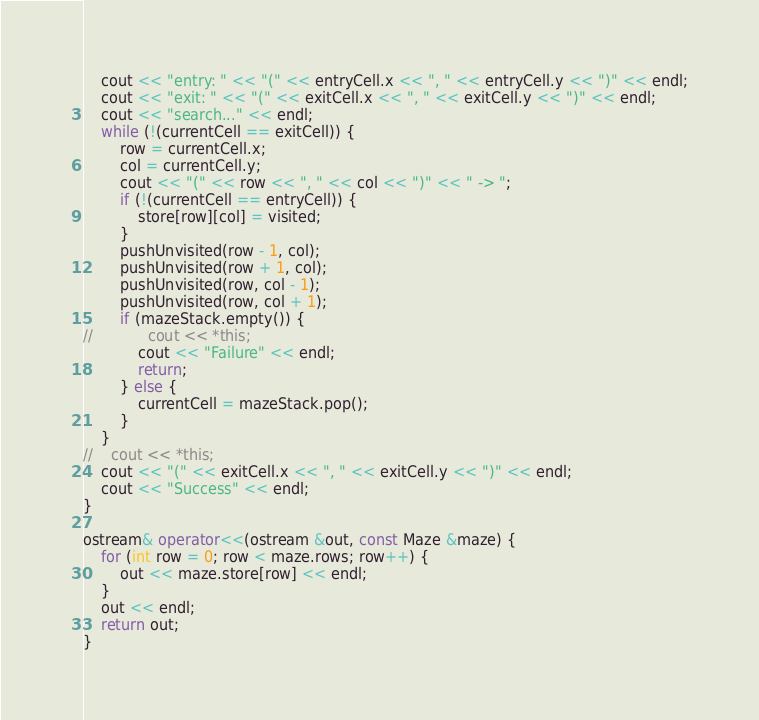Convert code to text. <code><loc_0><loc_0><loc_500><loc_500><_C++_>    cout << "entry: " << "(" << entryCell.x << ", " << entryCell.y << ")" << endl;
    cout << "exit: " << "(" << exitCell.x << ", " << exitCell.y << ")" << endl;
    cout << "search..." << endl;
    while (!(currentCell == exitCell)) {
        row = currentCell.x;
        col = currentCell.y;
        cout << "(" << row << ", " << col << ")" << " -> ";
        if (!(currentCell == entryCell)) {
            store[row][col] = visited;
        }
        pushUnvisited(row - 1, col);
        pushUnvisited(row + 1, col);
        pushUnvisited(row, col - 1);
        pushUnvisited(row, col + 1);
        if (mazeStack.empty()) {
//            cout << *this;
            cout << "Failure" << endl;
            return;
        } else {
            currentCell = mazeStack.pop();
        }
    }
//    cout << *this;
    cout << "(" << exitCell.x << ", " << exitCell.y << ")" << endl;
    cout << "Success" << endl;
}

ostream& operator<<(ostream &out, const Maze &maze) {
    for (int row = 0; row < maze.rows; row++) {
        out << maze.store[row] << endl;
    }
    out << endl;
    return out;
}


</code> 